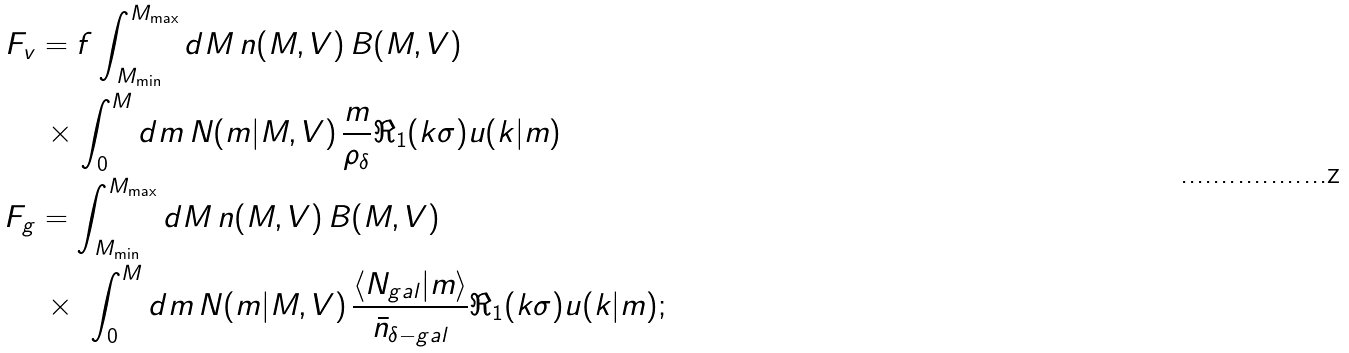Convert formula to latex. <formula><loc_0><loc_0><loc_500><loc_500>F _ { v } & = f \int _ { M _ { \min } } ^ { M _ { \max } } d M \, n ( M , V ) \, B ( M , V ) \\ \ & \, \times \int _ { 0 } ^ { M } d m \, N ( m | M , V ) \, \frac { m } { \rho _ { \delta } } \Re _ { 1 } ( k \sigma ) u ( k | m ) \\ F _ { g } & = \int _ { M _ { \min } } ^ { M _ { \max } } d M \, n ( M , V ) \, B ( M , V ) \\ \ & \, \times \ \int _ { 0 } ^ { M } d m \, N ( m | M , V ) \, \frac { \langle N _ { g a l } | m \rangle } { \bar { n } _ { \delta - g a l } } \Re _ { 1 } ( k \sigma ) u ( k | m ) ;</formula> 